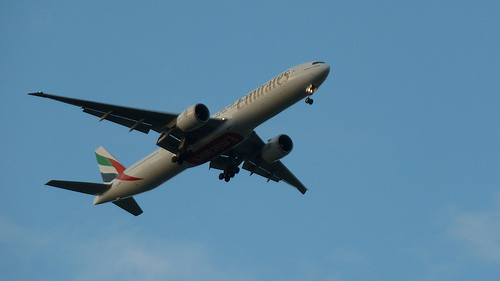Can you tell what type of airplane this is? It appears to be a commercial jetliner, possibly belonging to an international airline based on its livery. 